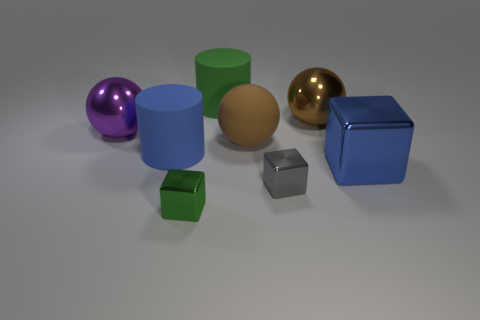Does the tiny gray metal thing that is to the right of the big purple shiny sphere have the same shape as the large blue thing on the right side of the tiny green object?
Ensure brevity in your answer.  Yes. What is the color of the shiny cube that is both left of the brown metallic sphere and behind the tiny green block?
Provide a succinct answer. Gray. There is a large matte ball; is it the same color as the large metal sphere that is to the right of the small green metallic block?
Keep it short and to the point. Yes. What is the size of the object that is both in front of the big blue matte object and behind the small gray cube?
Offer a terse response. Large. There is a matte cylinder in front of the cylinder behind the large metallic object that is behind the big purple object; what size is it?
Make the answer very short. Large. Are there any green rubber cylinders to the right of the blue cylinder?
Provide a succinct answer. Yes. Do the matte sphere and the blue shiny thing in front of the large brown rubber ball have the same size?
Ensure brevity in your answer.  Yes. What number of other objects are the same material as the small gray object?
Make the answer very short. 4. What shape is the object that is both to the left of the tiny gray cube and in front of the blue cube?
Your response must be concise. Cube. Do the cylinder that is behind the big blue matte object and the gray metal cube that is in front of the big blue rubber cylinder have the same size?
Provide a short and direct response. No. 